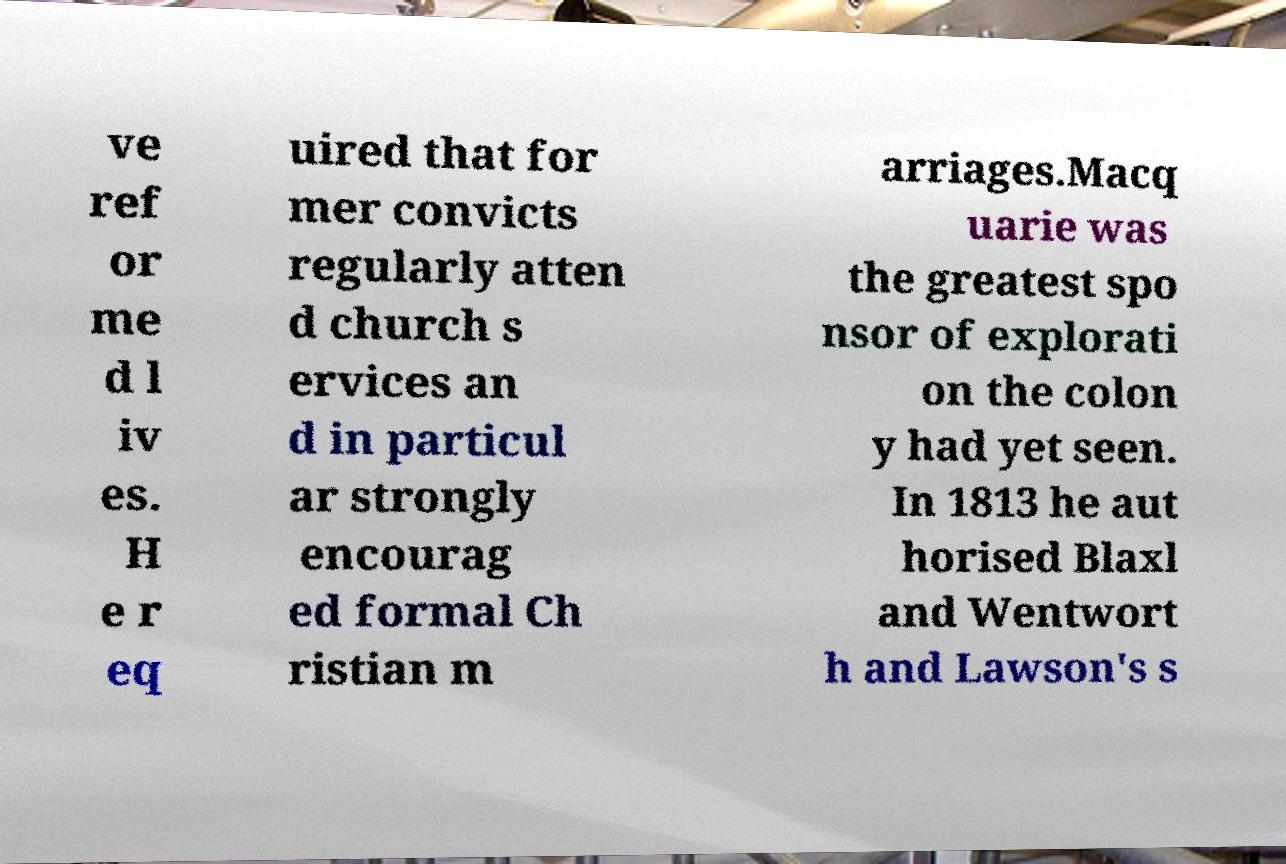Could you assist in decoding the text presented in this image and type it out clearly? ve ref or me d l iv es. H e r eq uired that for mer convicts regularly atten d church s ervices an d in particul ar strongly encourag ed formal Ch ristian m arriages.Macq uarie was the greatest spo nsor of explorati on the colon y had yet seen. In 1813 he aut horised Blaxl and Wentwort h and Lawson's s 